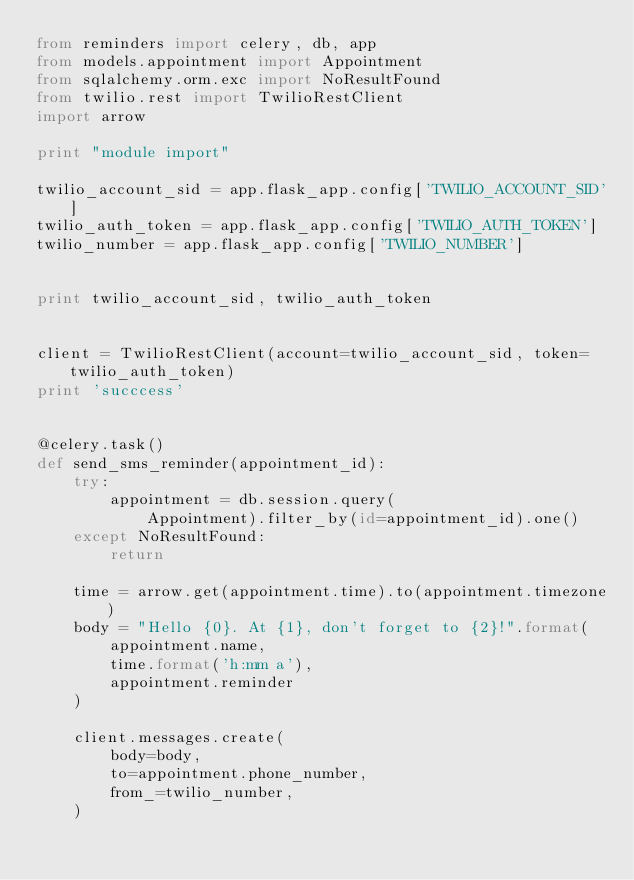<code> <loc_0><loc_0><loc_500><loc_500><_Python_>from reminders import celery, db, app
from models.appointment import Appointment
from sqlalchemy.orm.exc import NoResultFound
from twilio.rest import TwilioRestClient
import arrow

print "module import"

twilio_account_sid = app.flask_app.config['TWILIO_ACCOUNT_SID']
twilio_auth_token = app.flask_app.config['TWILIO_AUTH_TOKEN']
twilio_number = app.flask_app.config['TWILIO_NUMBER']


print twilio_account_sid, twilio_auth_token


client = TwilioRestClient(account=twilio_account_sid, token=twilio_auth_token)
print 'succcess'


@celery.task()
def send_sms_reminder(appointment_id):
    try:
        appointment = db.session.query(
            Appointment).filter_by(id=appointment_id).one()
    except NoResultFound:
        return

    time = arrow.get(appointment.time).to(appointment.timezone)
    body = "Hello {0}. At {1}, don't forget to {2}!".format(
        appointment.name,
        time.format('h:mm a'),
        appointment.reminder
    )

    client.messages.create(
        body=body,
        to=appointment.phone_number,
        from_=twilio_number,
    )
</code> 